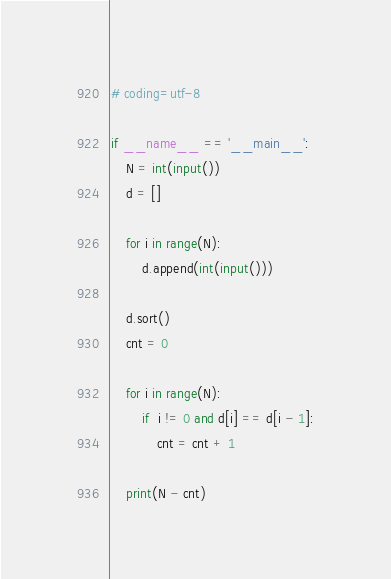<code> <loc_0><loc_0><loc_500><loc_500><_Python_># coding=utf-8

if __name__ == '__main__':
    N = int(input())
    d = []

    for i in range(N):
        d.append(int(input()))

    d.sort()
    cnt = 0

    for i in range(N):
        if  i != 0 and d[i] == d[i - 1]:
            cnt = cnt + 1

    print(N - cnt)</code> 